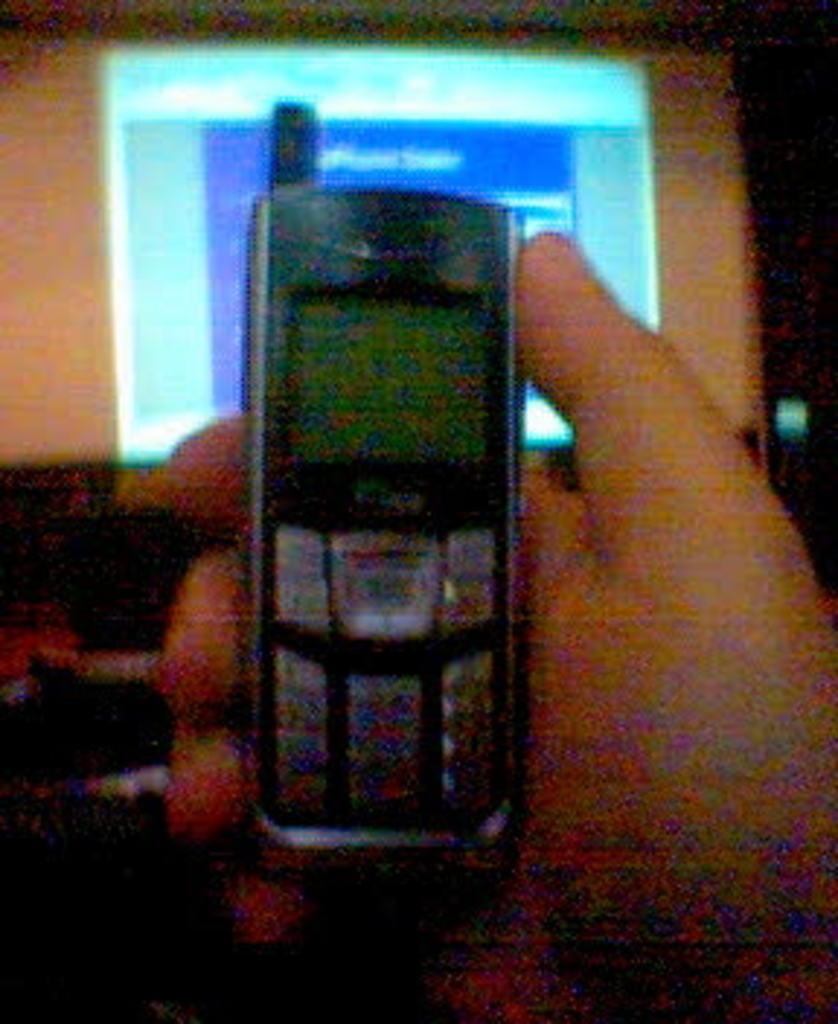What is the main subject of the image? There is a person in the image. What is the person holding in the image? The person is holding a mobile. What can be seen in the background of the image? There is a screen or monitor in the background of the image. What type of produce is being shaken in the image? There is no produce or shaking activity present in the image. What kind of drum is the person playing in the image? There is no drum or musical activity present in the image. 